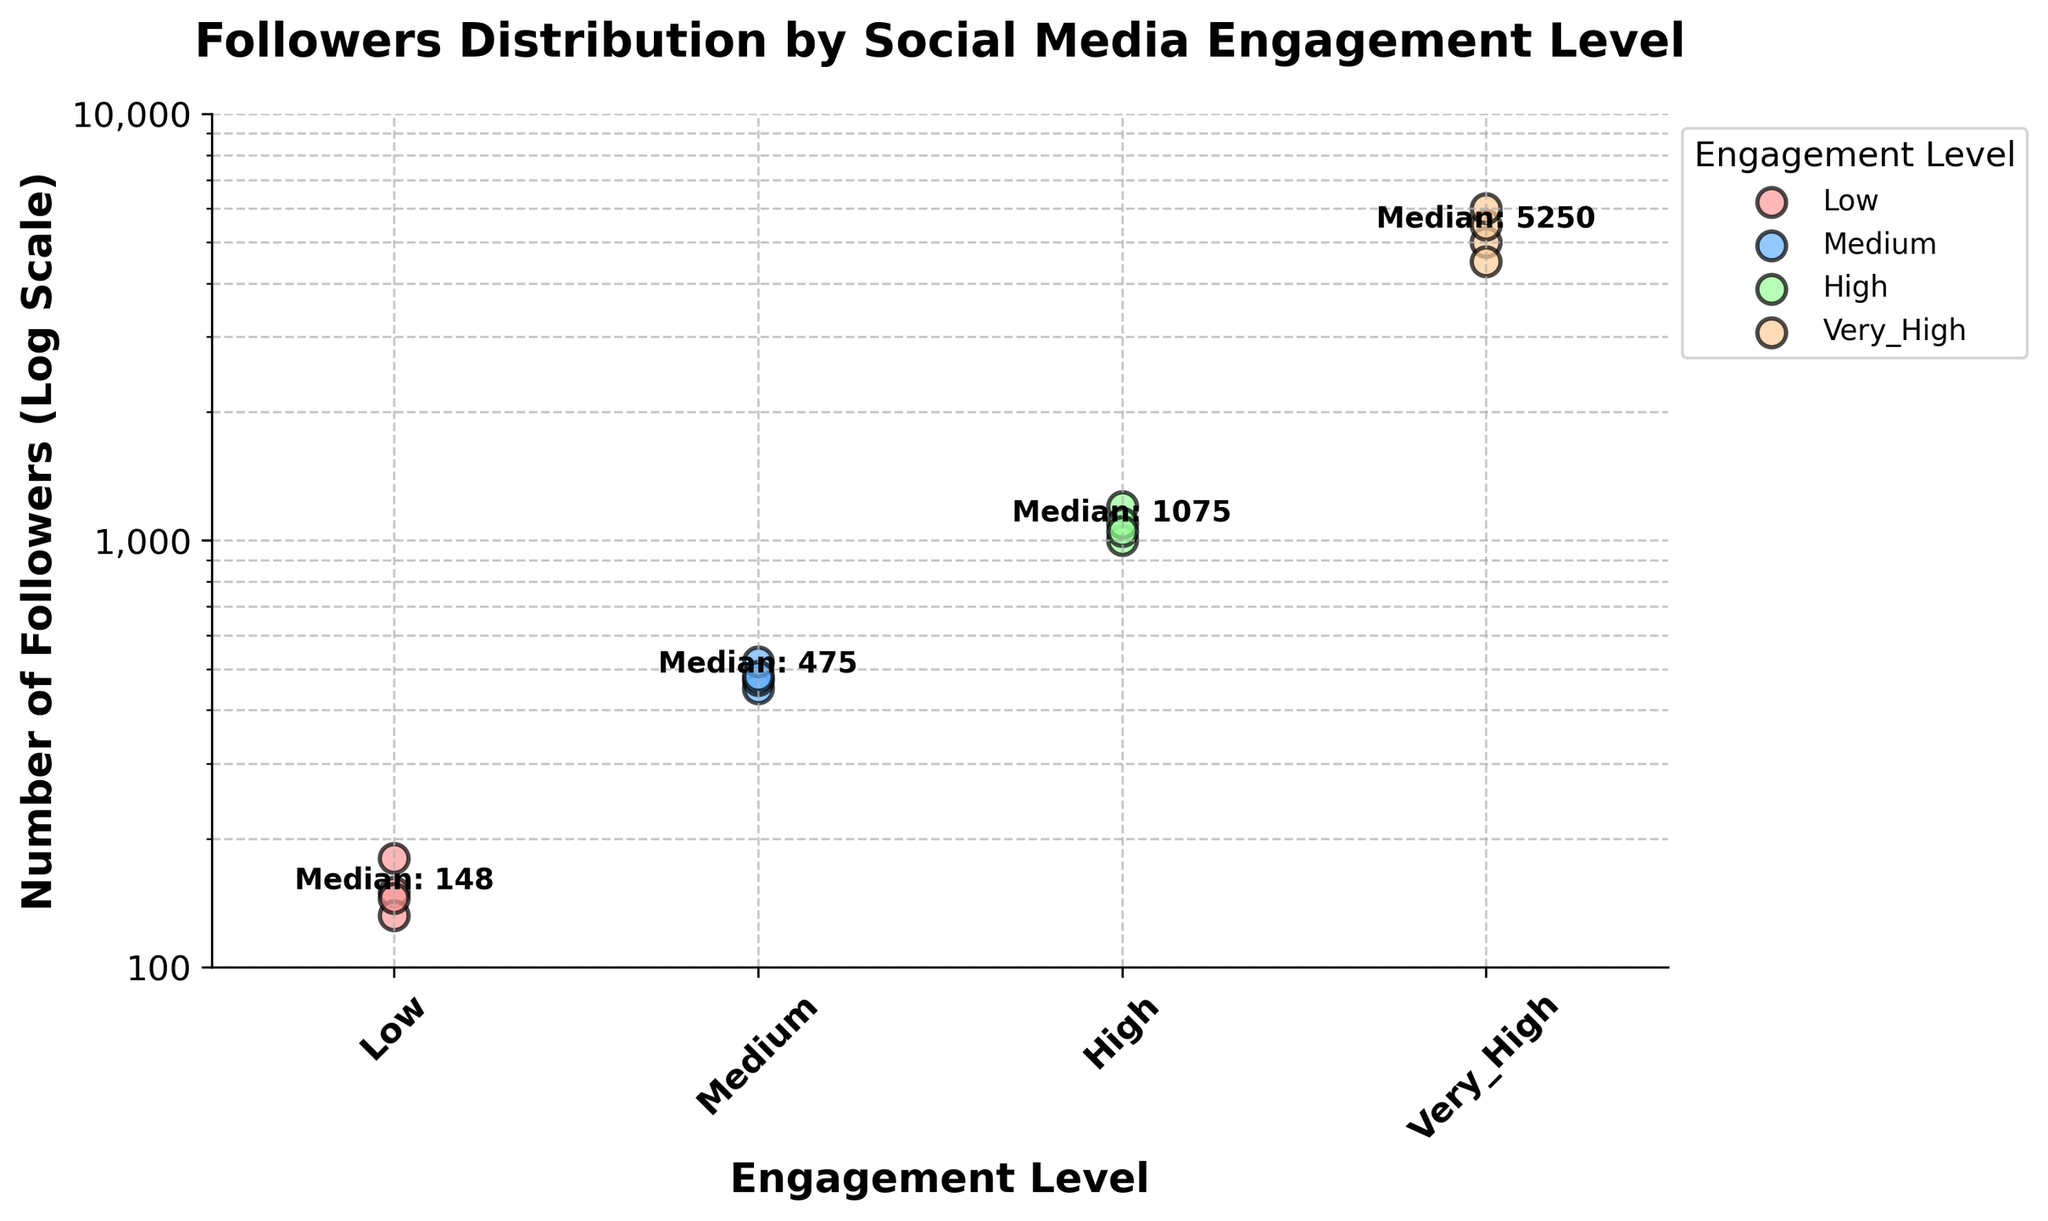What's the title of the figure? The title of the figure is displayed at the top and reads "Followers Distribution by Social Media Engagement Level".
Answer: Followers Distribution by Social Media Engagement Level What are the four engagement levels shown on the x-axis? The x-axis labels indicate the four engagement levels: Low, Medium, High, and Very High.
Answer: Low, Medium, High, Very High How are the data points for each engagement level visually represented in the plot? The data points for each engagement level are represented as colored scatter points with black edges. Each engagement level has a unique color: pink for Low, blue for Medium, green for High, and orange for Very High.
Answer: Colored scatter points with black edges What is the y-axis scale used in the plot? The y-axis uses a logarithmic scale, as indicated by the 'Log Scale' label.
Answer: Logarithmic scale Which engagement level has the widest range of followers? The Very High engagement level has the widest range of followers, with values between 4500 and 6000.
Answer: Very High What is the median number of followers for the Medium engagement level? The Medium engagement level has a median number of followers annotated as 475 in the figure.
Answer: 475 Compare the median number of followers between Low and High engagement levels. Which one is greater? The median number of followers for Low engagement is 145, whereas for High engagement, it is 1100. Thus, the median is greater for High engagement.
Answer: High What are the minimum and maximum y-axis values shown in the plot? The y-axis ranges from 100 to 10,000, as indicated by the tick marks.
Answer: 100, 10,000 How does the number of followers change with varying engagement levels? As the engagement level increases from Low to Very High, the number of followers also increases. This trend is evident since the follower counts for Low, Medium, High, and Very High engagement levels go up progressively.
Answer: Increases with higher engagement Which engagement level has no overlap with other levels in the number of followers represented? The Very High engagement level clearly stands out without overlapping with other levels, as its followers range between 4500 and 6000, a range not shared with any other levels.
Answer: Very High 